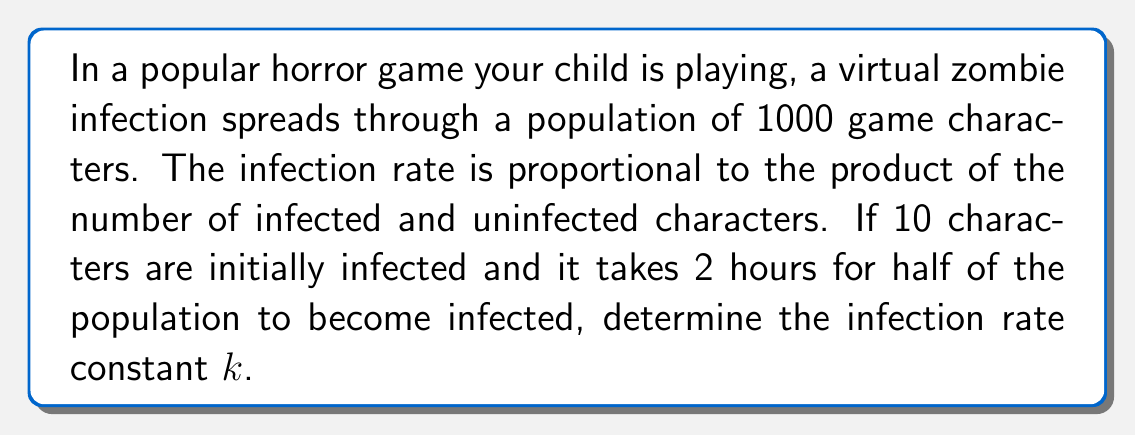Could you help me with this problem? Let's approach this step-by-step:

1) Let $I(t)$ be the number of infected characters at time $t$, and $N$ be the total population.

2) The differential equation modeling this spread is:

   $$\frac{dI}{dt} = kI(N-I)$$

   where $k$ is the infection rate constant we need to find.

3) We can solve this equation by separating variables:

   $$\int \frac{dI}{I(N-I)} = \int k dt$$

4) The left side integrates to:

   $$\frac{1}{N} \ln(\frac{I}{N-I}) = kt + C$$

5) Using the initial condition $I(0) = 10$, we can find $C$:

   $$\frac{1}{1000} \ln(\frac{10}{990}) = C$$

6) Now, we know that at $t = 2$ hours, $I(2) = 500$ (half the population). Substituting this:

   $$\frac{1}{1000} \ln(\frac{500}{500}) - \frac{1}{1000} \ln(\frac{10}{990}) = 2k$$

7) Simplifying:

   $$\frac{1}{1000} \ln(49.5) = 2k$$

8) Solving for $k$:

   $$k = \frac{\ln(49.5)}{2000} \approx 0.001955$$
Answer: $k \approx 0.001955$ per character per hour 